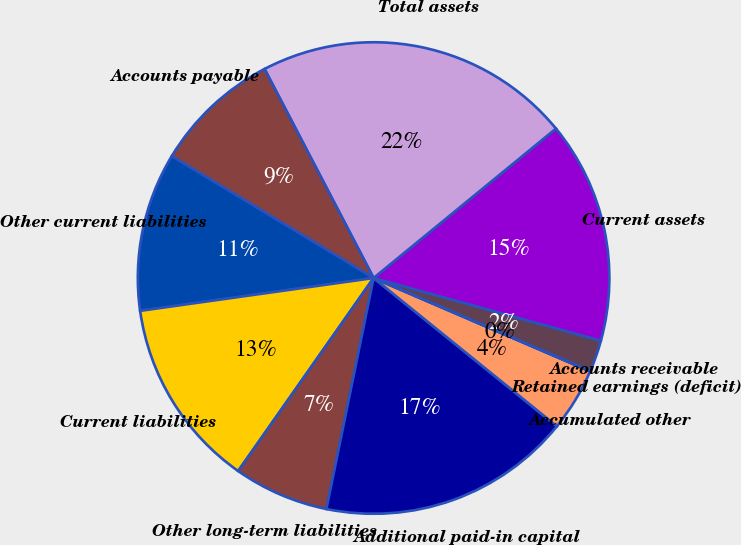<chart> <loc_0><loc_0><loc_500><loc_500><pie_chart><fcel>Accounts receivable<fcel>Current assets<fcel>Total assets<fcel>Accounts payable<fcel>Other current liabilities<fcel>Current liabilities<fcel>Other long-term liabilities<fcel>Additional paid-in capital<fcel>Accumulated other<fcel>Retained earnings (deficit)<nl><fcel>2.18%<fcel>15.21%<fcel>21.73%<fcel>8.7%<fcel>10.87%<fcel>13.04%<fcel>6.53%<fcel>17.38%<fcel>4.35%<fcel>0.01%<nl></chart> 